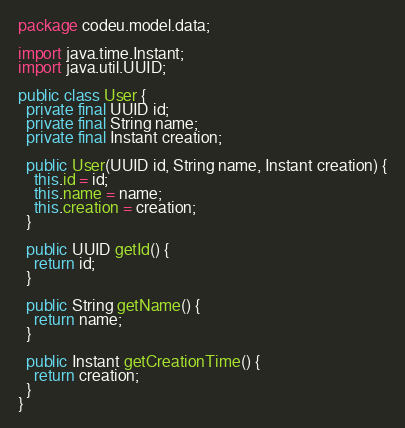<code> <loc_0><loc_0><loc_500><loc_500><_Java_>package codeu.model.data;

import java.time.Instant;
import java.util.UUID;

public class User {
  private final UUID id;
  private final String name;
  private final Instant creation;

  public User(UUID id, String name, Instant creation) {
    this.id = id;
    this.name = name;
    this.creation = creation;
  }

  public UUID getId() {
    return id;
  }

  public String getName() {
    return name;
  }

  public Instant getCreationTime() {
    return creation;
  }
}
</code> 